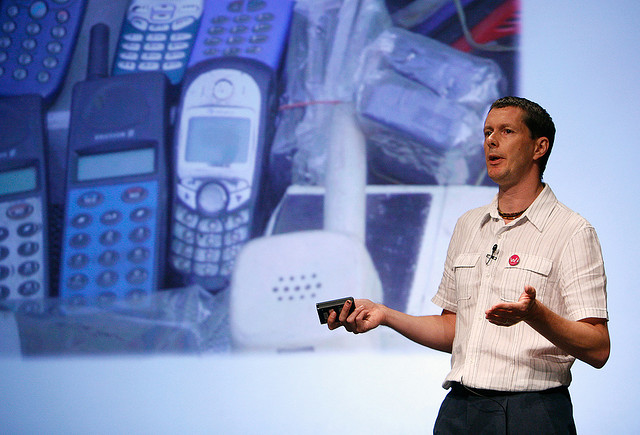<image>Are those iPhones in the background? I don't know if those are iPhones in the background. Are those iPhones in the background? I don't know if those are iPhones in the background. It can be either yes or no. 